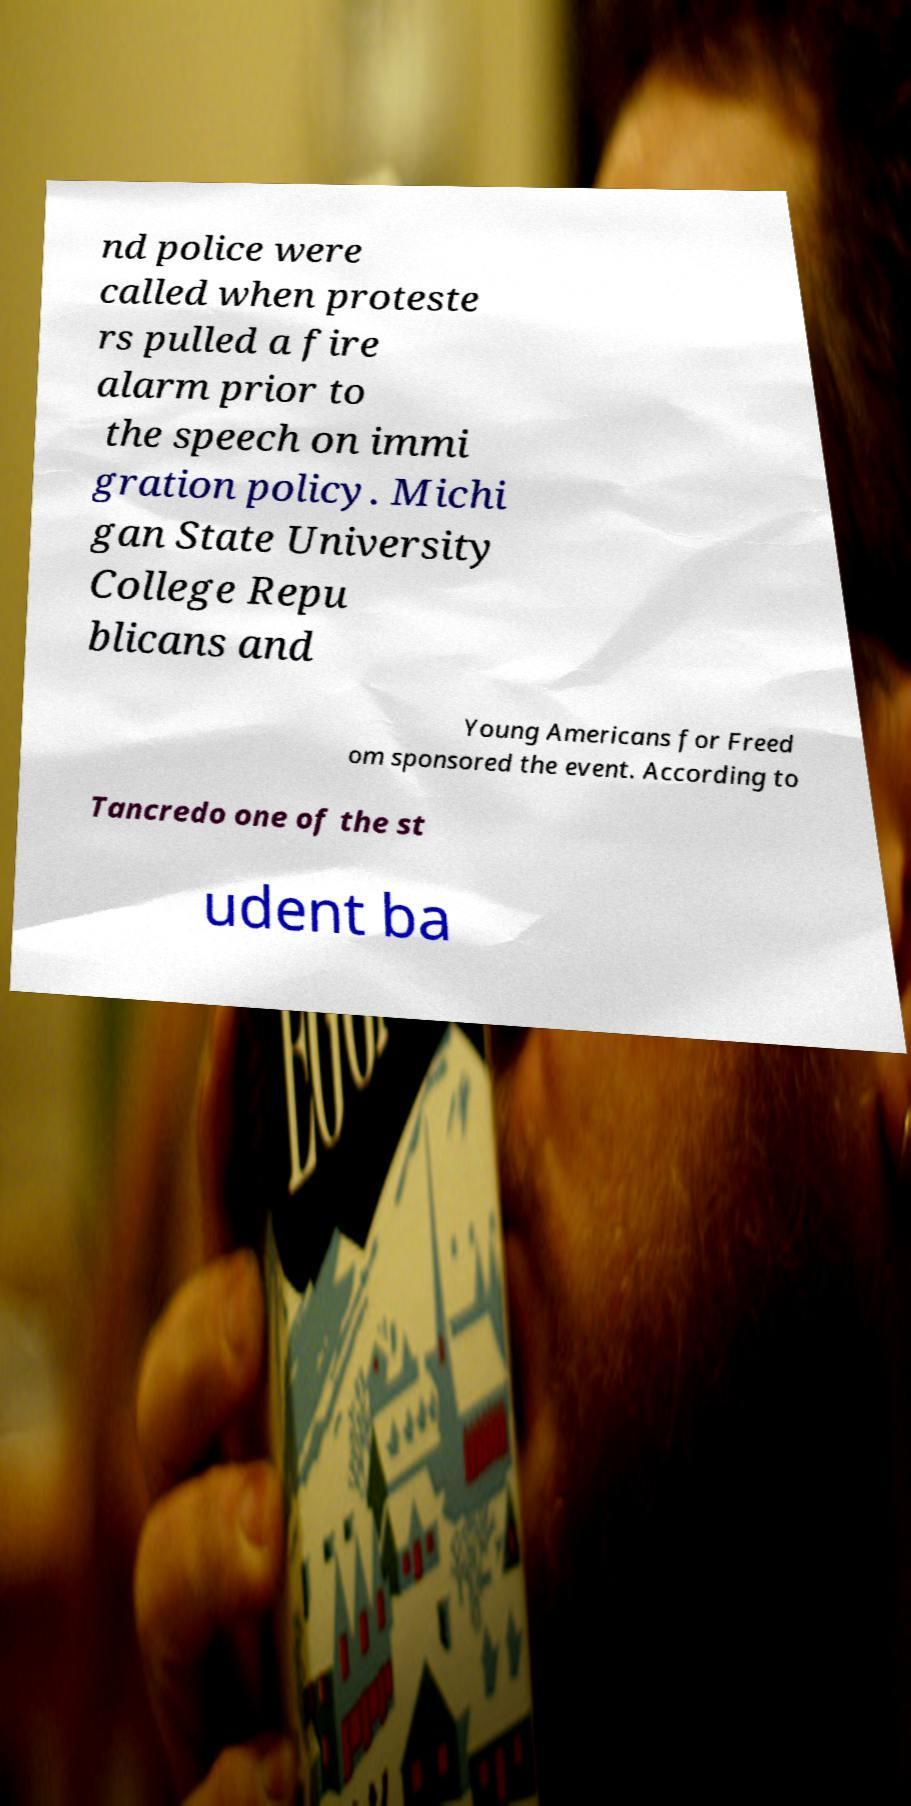Please read and relay the text visible in this image. What does it say? nd police were called when proteste rs pulled a fire alarm prior to the speech on immi gration policy. Michi gan State University College Repu blicans and Young Americans for Freed om sponsored the event. According to Tancredo one of the st udent ba 